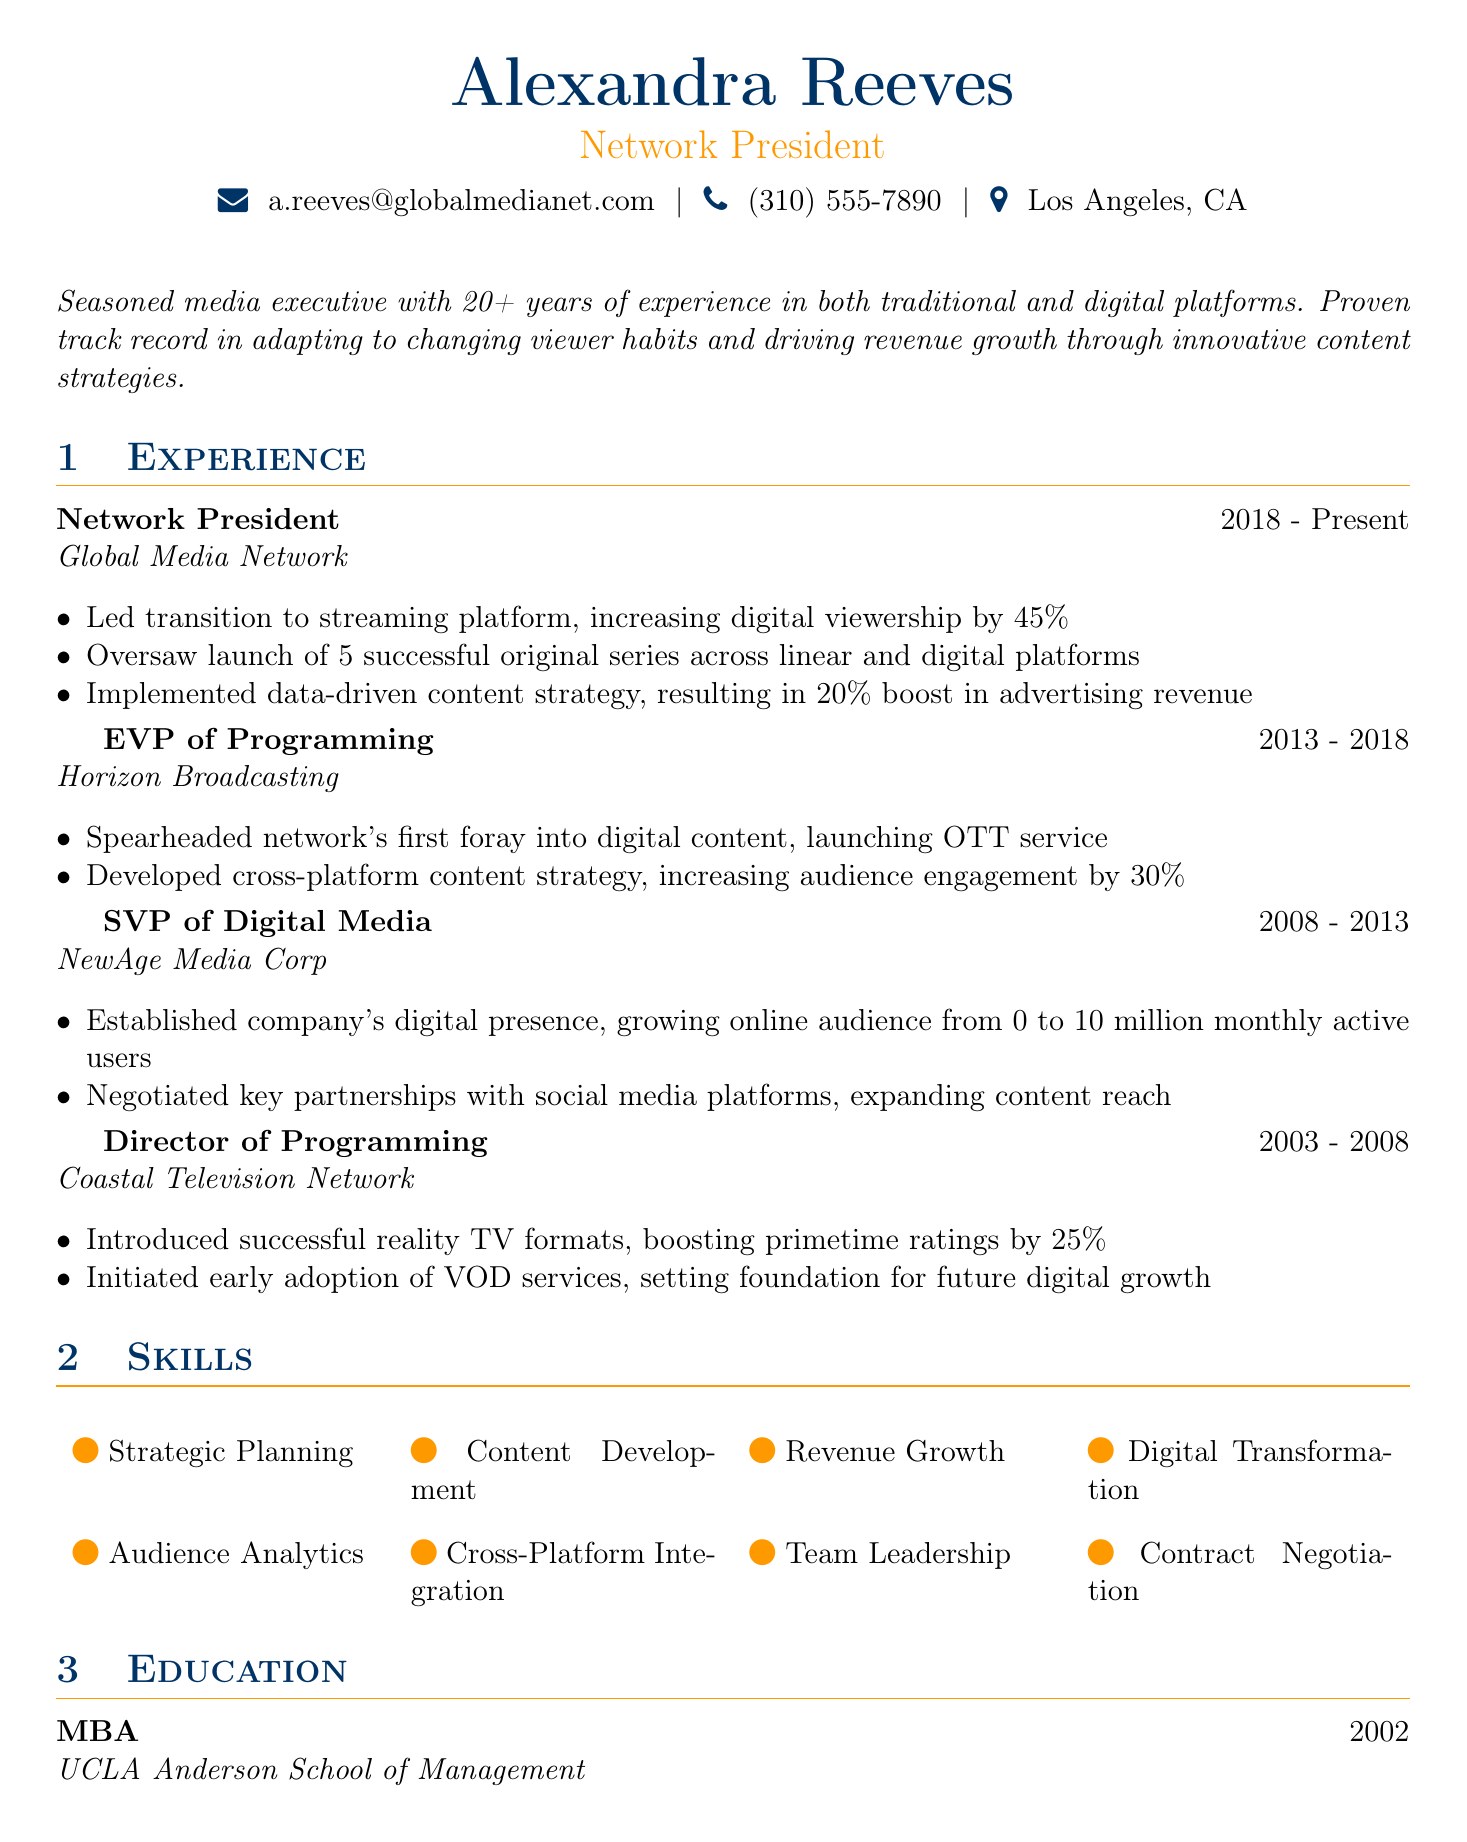What is Alexandra Reeves' current position? The document states that her current position is "Network President."
Answer: Network President How many years of experience does Alexandra have? The professional summary indicates that she has "20+ years of experience."
Answer: 20+ What was the percentage increase in digital viewership at Global Media Network? The achievements mention an increase of "45%" in digital viewership.
Answer: 45% Which company did she work for as SVP of Digital Media? The career timeline lists "NewAge Media Corp" as the company where she worked as SVP of Digital Media.
Answer: NewAge Media Corp What educational degree does Alexandra Reeves hold? The education section specifies that she earned an "MBA."
Answer: MBA Which position did she hold prior to becoming Network President? The document indicates she was "EVP of Programming" before becoming Network President.
Answer: EVP of Programming How many original series did Alexandra oversee the launch of at Global Media Network? The achievements state she oversaw the launch of "5 successful original series."
Answer: 5 What was a significant achievement as SVP of Digital Media? The achievements highlighted that she "grew online audience from 0 to 10 million monthly active users."
Answer: 10 million What initiative did Alexandra introduce to boost primetime ratings? The document notes she "introduced successful reality TV formats" at Coastal Television Network.
Answer: successful reality TV formats 